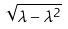Convert formula to latex. <formula><loc_0><loc_0><loc_500><loc_500>\sqrt { \lambda - \lambda ^ { 2 } }</formula> 